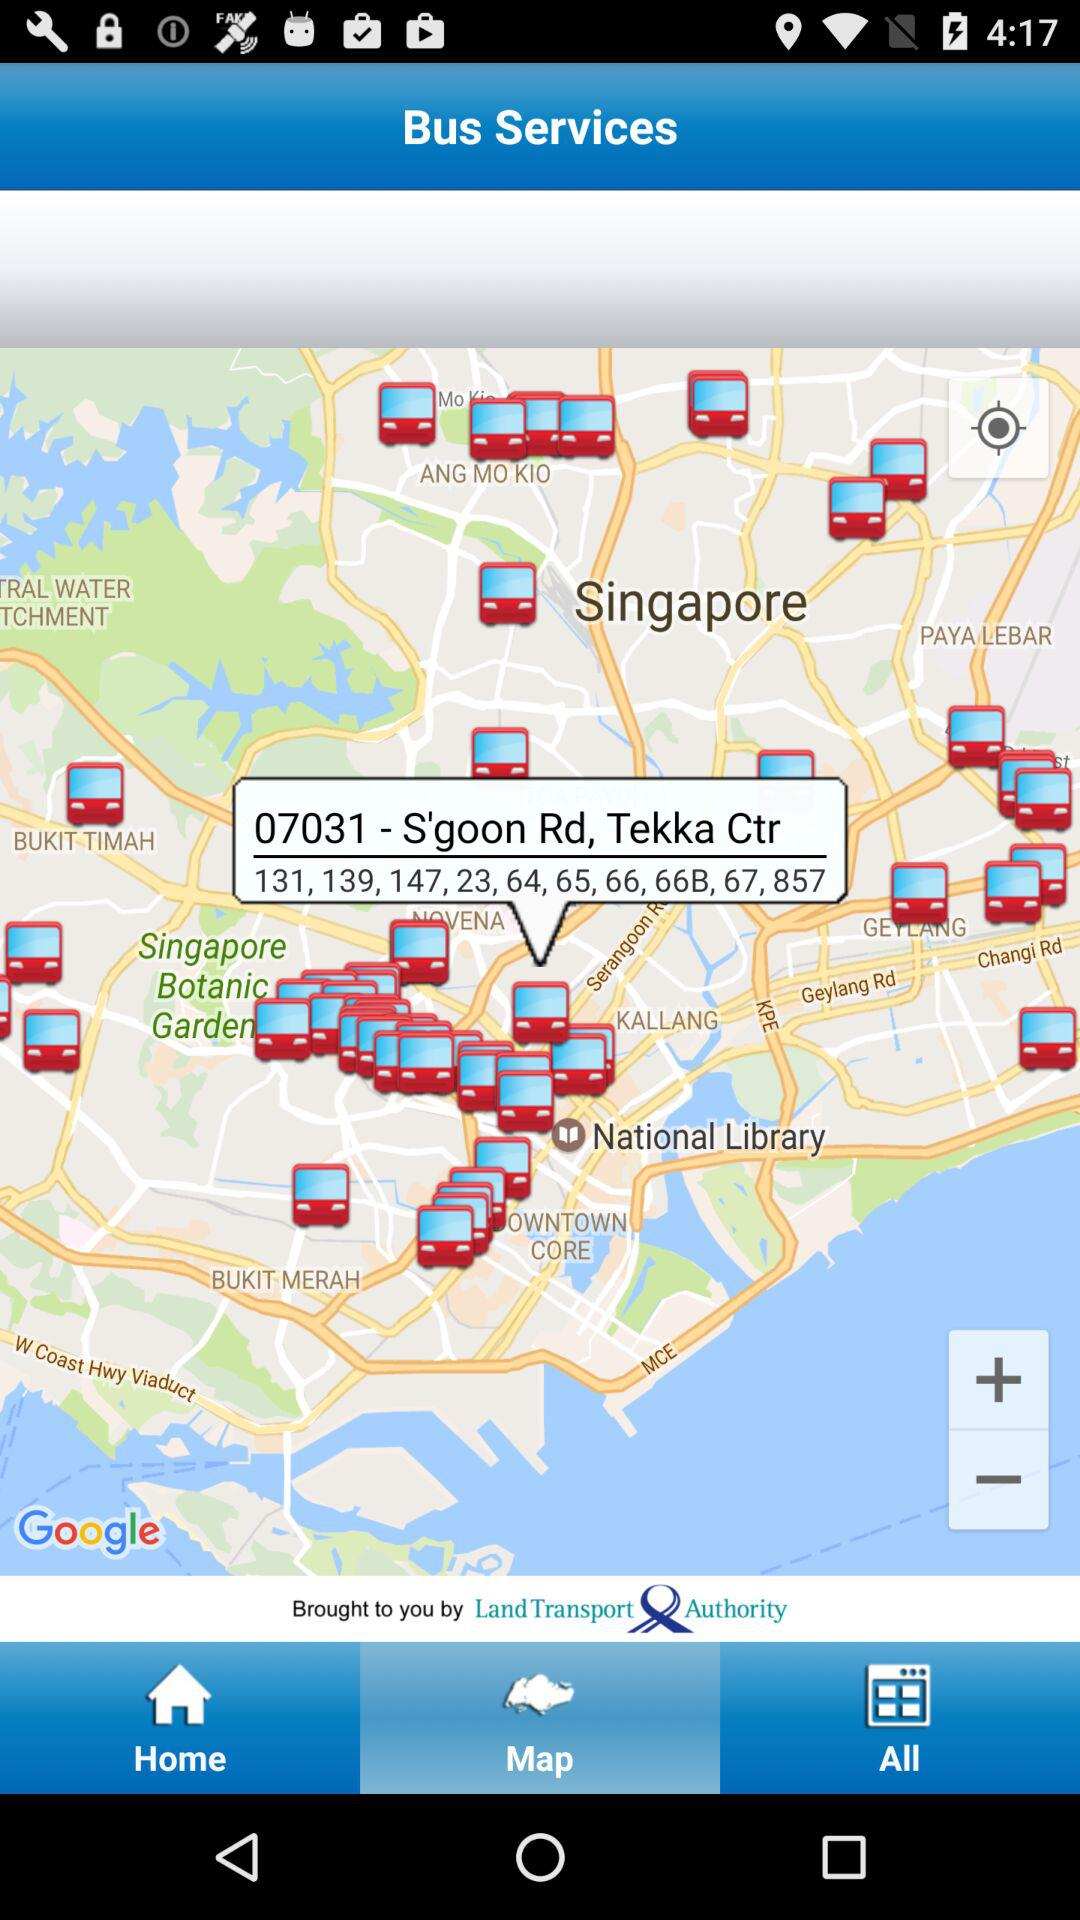What is the name of the bus stop? The name of the bus stop is "S'goon Rd, Tekka Ctr". 